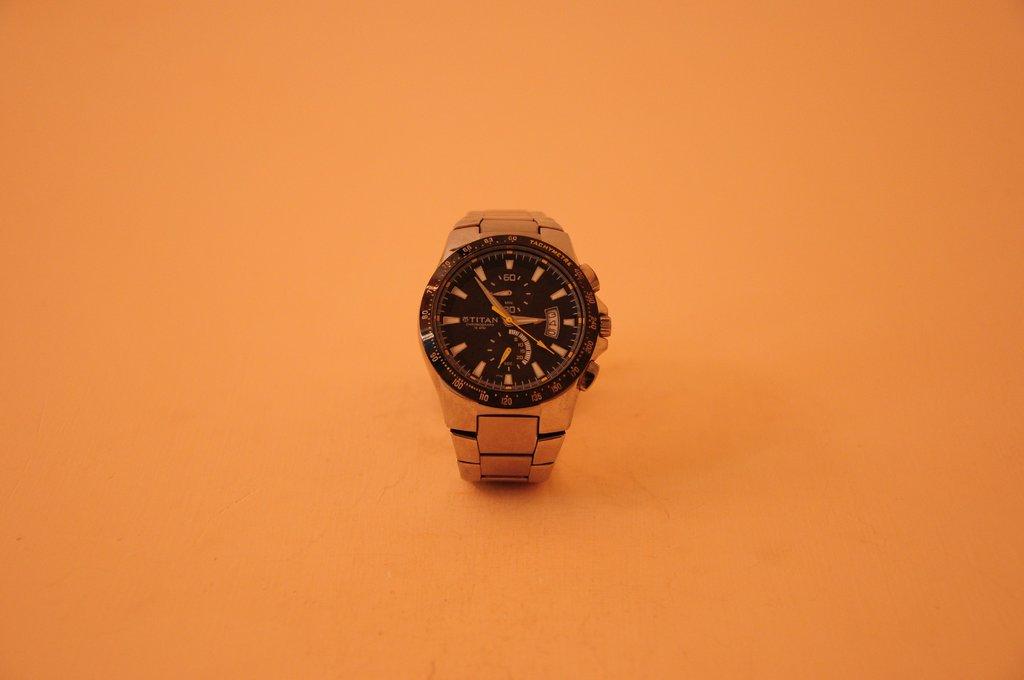What time is shown?
Your answer should be very brief. 2:49. Who makes the watch?
Offer a very short reply. Titan. 